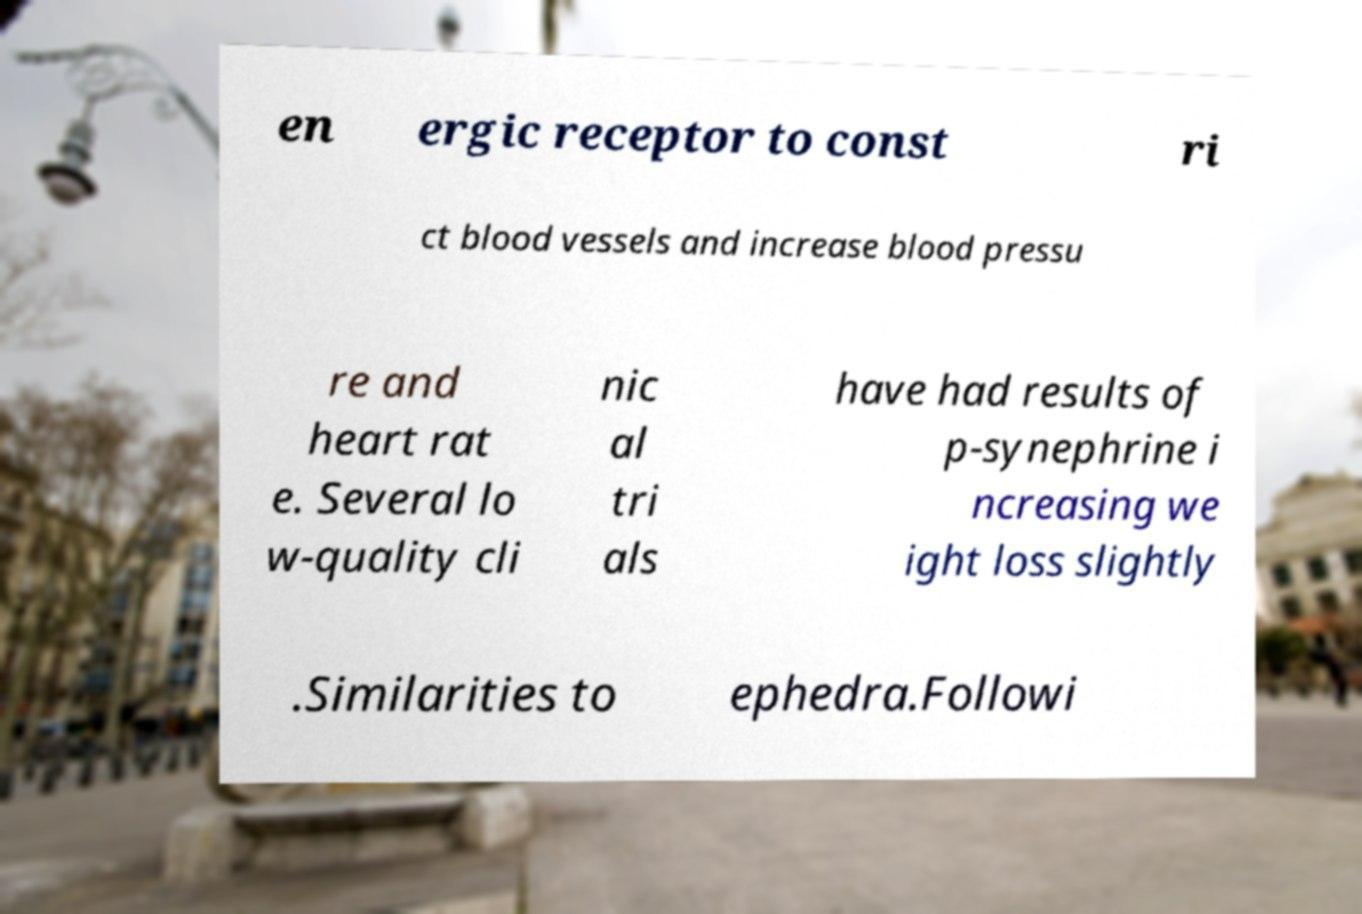Could you assist in decoding the text presented in this image and type it out clearly? en ergic receptor to const ri ct blood vessels and increase blood pressu re and heart rat e. Several lo w-quality cli nic al tri als have had results of p-synephrine i ncreasing we ight loss slightly .Similarities to ephedra.Followi 